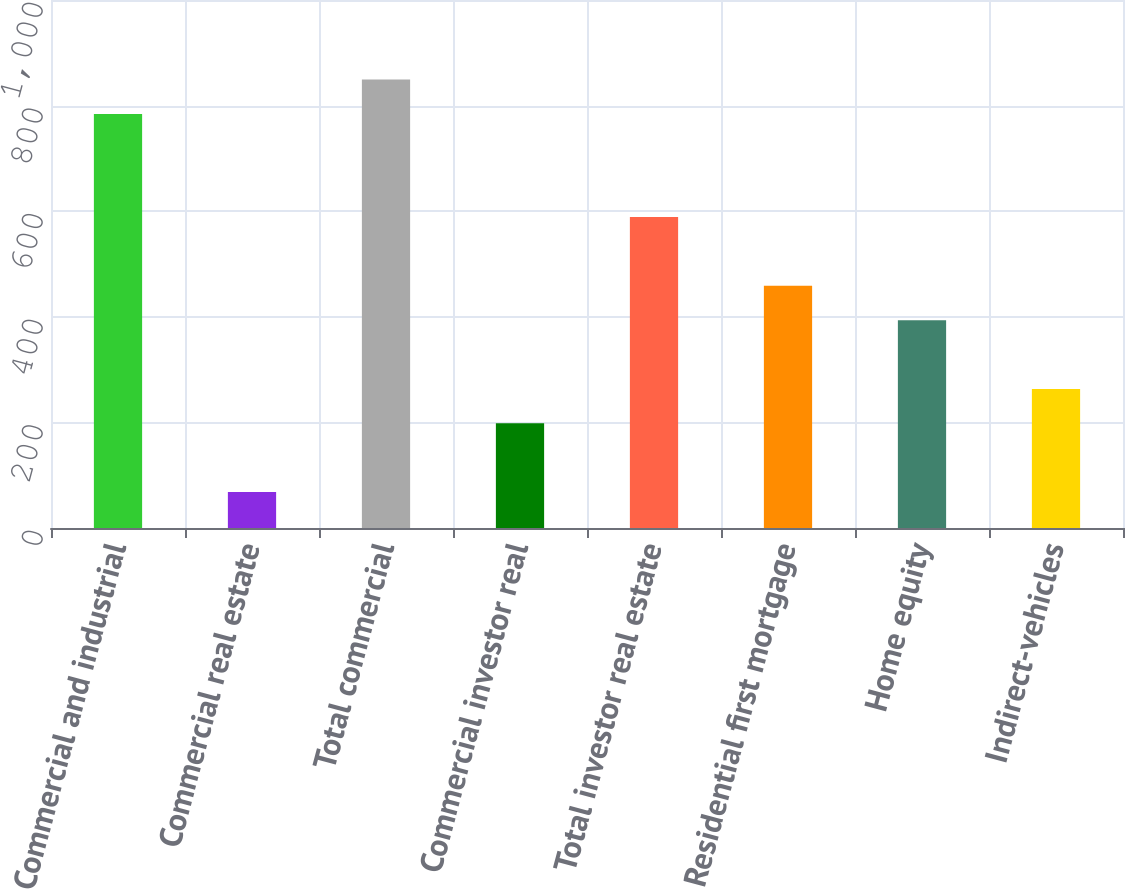Convert chart. <chart><loc_0><loc_0><loc_500><loc_500><bar_chart><fcel>Commercial and industrial<fcel>Commercial real estate<fcel>Total commercial<fcel>Commercial investor real<fcel>Total investor real estate<fcel>Residential first mortgage<fcel>Home equity<fcel>Indirect-vehicles<nl><fcel>784.2<fcel>68.1<fcel>849.3<fcel>198.3<fcel>588.9<fcel>458.7<fcel>393.6<fcel>263.4<nl></chart> 